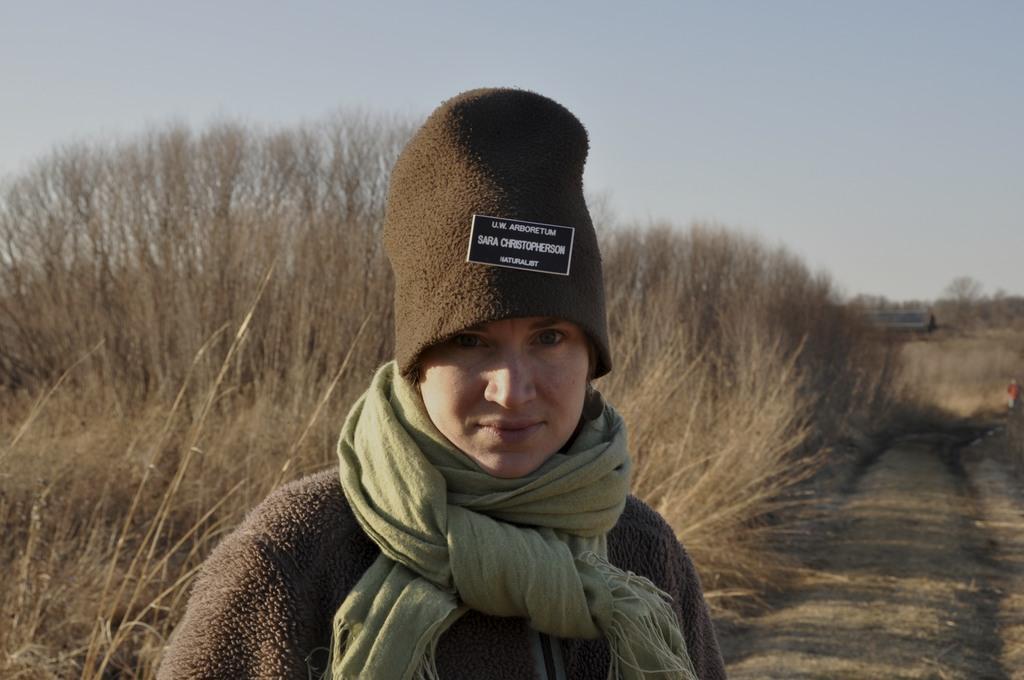Describe this image in one or two sentences. In this image I can see a person wearing a scarf and cap and in the background I can see the sky. 